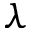Convert formula to latex. <formula><loc_0><loc_0><loc_500><loc_500>\lambda</formula> 